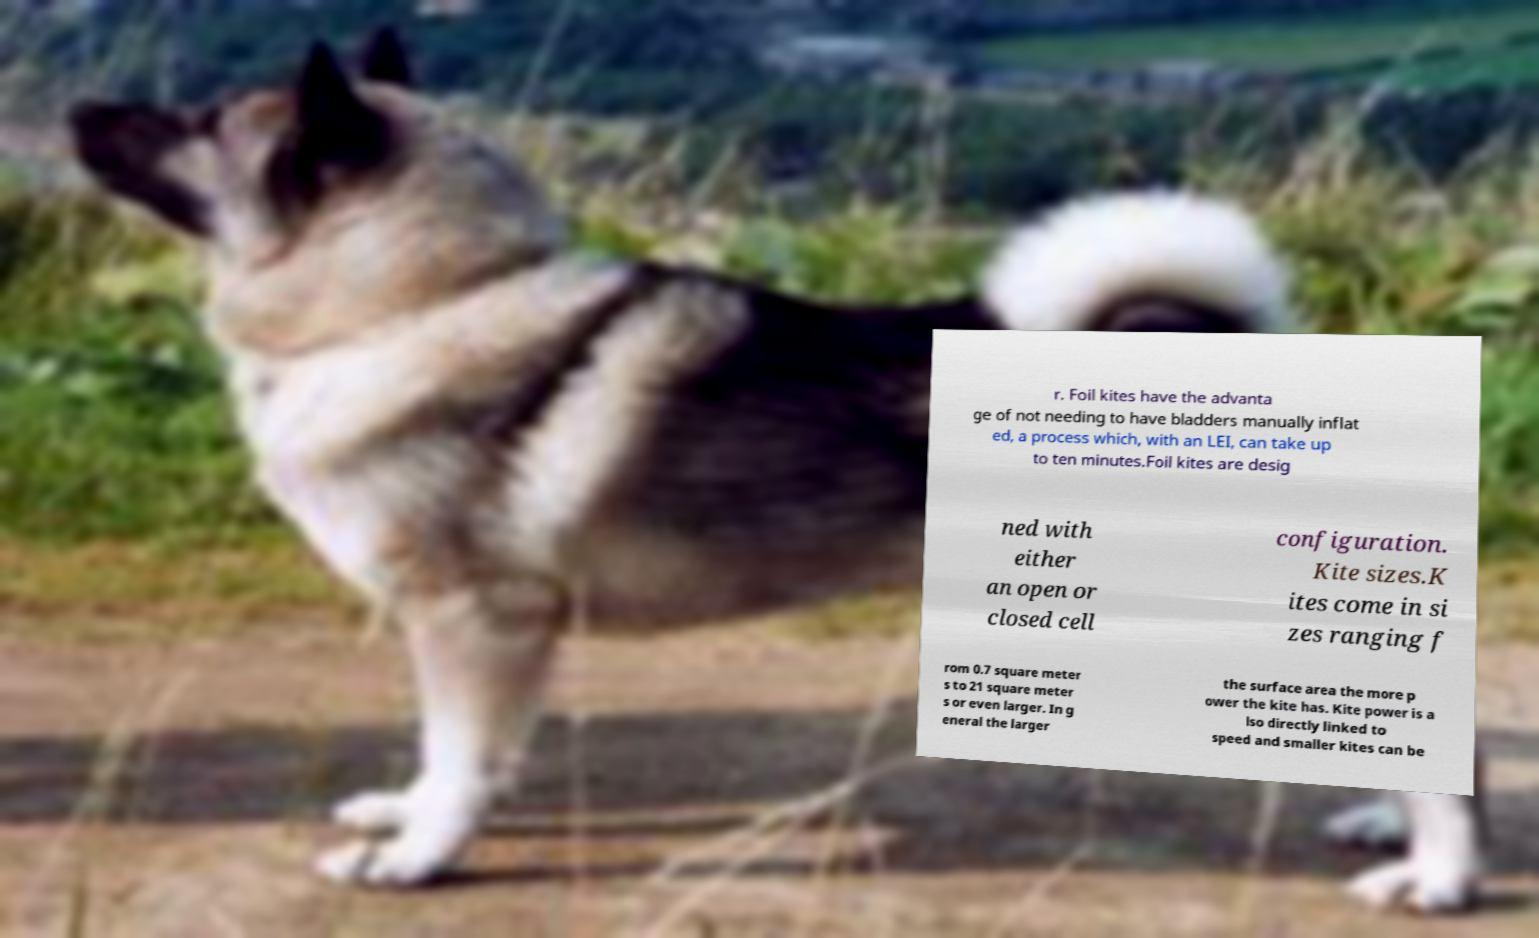What messages or text are displayed in this image? I need them in a readable, typed format. r. Foil kites have the advanta ge of not needing to have bladders manually inflat ed, a process which, with an LEI, can take up to ten minutes.Foil kites are desig ned with either an open or closed cell configuration. Kite sizes.K ites come in si zes ranging f rom 0.7 square meter s to 21 square meter s or even larger. In g eneral the larger the surface area the more p ower the kite has. Kite power is a lso directly linked to speed and smaller kites can be 